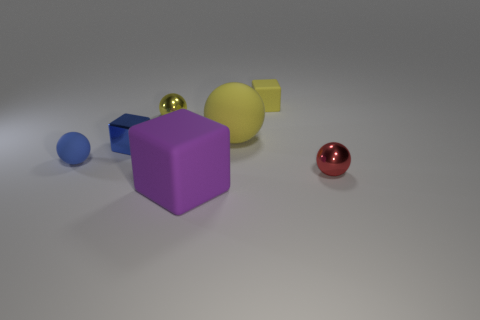Subtract 1 spheres. How many spheres are left? 3 Subtract all small blocks. How many blocks are left? 1 Subtract all blue spheres. How many spheres are left? 3 Add 3 tiny yellow cylinders. How many objects exist? 10 Subtract all purple balls. Subtract all blue blocks. How many balls are left? 4 Subtract all balls. How many objects are left? 3 Add 3 large matte blocks. How many large matte blocks are left? 4 Add 4 tiny cyan metallic cubes. How many tiny cyan metallic cubes exist? 4 Subtract 1 blue spheres. How many objects are left? 6 Subtract all cyan matte cubes. Subtract all large matte objects. How many objects are left? 5 